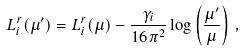Convert formula to latex. <formula><loc_0><loc_0><loc_500><loc_500>L _ { i } ^ { r } ( \mu ^ { \prime } ) = L _ { i } ^ { r } ( \mu ) - \frac { \gamma _ { i } } { 1 6 \pi ^ { 2 } } \log \left ( \frac { \mu ^ { \prime } } { \mu } \right ) \, ,</formula> 